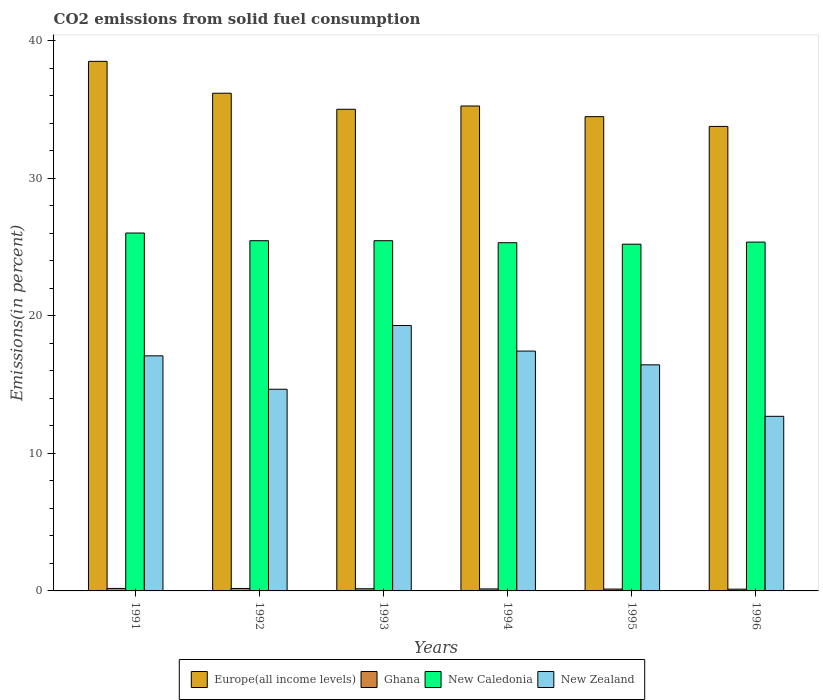How many groups of bars are there?
Offer a very short reply. 6. Are the number of bars on each tick of the X-axis equal?
Make the answer very short. Yes. In how many cases, is the number of bars for a given year not equal to the number of legend labels?
Ensure brevity in your answer.  0. What is the total CO2 emitted in Europe(all income levels) in 1994?
Provide a succinct answer. 35.26. Across all years, what is the maximum total CO2 emitted in Europe(all income levels)?
Your response must be concise. 38.51. Across all years, what is the minimum total CO2 emitted in New Zealand?
Ensure brevity in your answer.  12.7. In which year was the total CO2 emitted in Ghana maximum?
Ensure brevity in your answer.  1991. In which year was the total CO2 emitted in New Caledonia minimum?
Provide a succinct answer. 1995. What is the total total CO2 emitted in New Caledonia in the graph?
Your answer should be compact. 152.85. What is the difference between the total CO2 emitted in New Caledonia in 1993 and that in 1996?
Your answer should be very brief. 0.1. What is the difference between the total CO2 emitted in Europe(all income levels) in 1991 and the total CO2 emitted in New Caledonia in 1995?
Give a very brief answer. 13.29. What is the average total CO2 emitted in Europe(all income levels) per year?
Offer a very short reply. 35.54. In the year 1992, what is the difference between the total CO2 emitted in New Zealand and total CO2 emitted in Ghana?
Provide a short and direct response. 14.49. In how many years, is the total CO2 emitted in Ghana greater than 18 %?
Offer a very short reply. 0. What is the ratio of the total CO2 emitted in New Caledonia in 1992 to that in 1995?
Provide a short and direct response. 1.01. What is the difference between the highest and the second highest total CO2 emitted in New Caledonia?
Your answer should be very brief. 0.56. What is the difference between the highest and the lowest total CO2 emitted in Europe(all income levels)?
Your answer should be compact. 4.73. In how many years, is the total CO2 emitted in New Caledonia greater than the average total CO2 emitted in New Caledonia taken over all years?
Your answer should be very brief. 1. Is the sum of the total CO2 emitted in Ghana in 1994 and 1995 greater than the maximum total CO2 emitted in New Zealand across all years?
Provide a short and direct response. No. Is it the case that in every year, the sum of the total CO2 emitted in New Caledonia and total CO2 emitted in Ghana is greater than the sum of total CO2 emitted in New Zealand and total CO2 emitted in Europe(all income levels)?
Offer a very short reply. Yes. What does the 1st bar from the left in 1991 represents?
Provide a short and direct response. Europe(all income levels). What does the 1st bar from the right in 1995 represents?
Your answer should be compact. New Zealand. What is the difference between two consecutive major ticks on the Y-axis?
Your answer should be compact. 10. Are the values on the major ticks of Y-axis written in scientific E-notation?
Your answer should be very brief. No. Does the graph contain any zero values?
Ensure brevity in your answer.  No. What is the title of the graph?
Your response must be concise. CO2 emissions from solid fuel consumption. What is the label or title of the X-axis?
Offer a terse response. Years. What is the label or title of the Y-axis?
Ensure brevity in your answer.  Emissions(in percent). What is the Emissions(in percent) in Europe(all income levels) in 1991?
Your response must be concise. 38.51. What is the Emissions(in percent) in Ghana in 1991?
Provide a succinct answer. 0.18. What is the Emissions(in percent) in New Caledonia in 1991?
Your answer should be compact. 26.02. What is the Emissions(in percent) of New Zealand in 1991?
Offer a terse response. 17.09. What is the Emissions(in percent) in Europe(all income levels) in 1992?
Offer a terse response. 36.19. What is the Emissions(in percent) of Ghana in 1992?
Make the answer very short. 0.18. What is the Emissions(in percent) of New Caledonia in 1992?
Ensure brevity in your answer.  25.47. What is the Emissions(in percent) of New Zealand in 1992?
Provide a short and direct response. 14.67. What is the Emissions(in percent) in Europe(all income levels) in 1993?
Ensure brevity in your answer.  35.02. What is the Emissions(in percent) in Ghana in 1993?
Offer a terse response. 0.16. What is the Emissions(in percent) in New Caledonia in 1993?
Ensure brevity in your answer.  25.47. What is the Emissions(in percent) of New Zealand in 1993?
Ensure brevity in your answer.  19.3. What is the Emissions(in percent) in Europe(all income levels) in 1994?
Your answer should be very brief. 35.26. What is the Emissions(in percent) in Ghana in 1994?
Ensure brevity in your answer.  0.14. What is the Emissions(in percent) of New Caledonia in 1994?
Provide a succinct answer. 25.32. What is the Emissions(in percent) in New Zealand in 1994?
Keep it short and to the point. 17.44. What is the Emissions(in percent) of Europe(all income levels) in 1995?
Make the answer very short. 34.48. What is the Emissions(in percent) of Ghana in 1995?
Offer a terse response. 0.14. What is the Emissions(in percent) in New Caledonia in 1995?
Make the answer very short. 25.21. What is the Emissions(in percent) of New Zealand in 1995?
Offer a terse response. 16.44. What is the Emissions(in percent) of Europe(all income levels) in 1996?
Offer a very short reply. 33.78. What is the Emissions(in percent) in Ghana in 1996?
Keep it short and to the point. 0.13. What is the Emissions(in percent) in New Caledonia in 1996?
Your answer should be compact. 25.36. What is the Emissions(in percent) of New Zealand in 1996?
Keep it short and to the point. 12.7. Across all years, what is the maximum Emissions(in percent) in Europe(all income levels)?
Keep it short and to the point. 38.51. Across all years, what is the maximum Emissions(in percent) of Ghana?
Give a very brief answer. 0.18. Across all years, what is the maximum Emissions(in percent) of New Caledonia?
Offer a very short reply. 26.02. Across all years, what is the maximum Emissions(in percent) of New Zealand?
Provide a short and direct response. 19.3. Across all years, what is the minimum Emissions(in percent) in Europe(all income levels)?
Your response must be concise. 33.78. Across all years, what is the minimum Emissions(in percent) of Ghana?
Your answer should be compact. 0.13. Across all years, what is the minimum Emissions(in percent) of New Caledonia?
Provide a short and direct response. 25.21. Across all years, what is the minimum Emissions(in percent) of New Zealand?
Give a very brief answer. 12.7. What is the total Emissions(in percent) in Europe(all income levels) in the graph?
Ensure brevity in your answer.  213.24. What is the total Emissions(in percent) in Ghana in the graph?
Offer a very short reply. 0.92. What is the total Emissions(in percent) of New Caledonia in the graph?
Offer a terse response. 152.85. What is the total Emissions(in percent) in New Zealand in the graph?
Your response must be concise. 97.63. What is the difference between the Emissions(in percent) in Europe(all income levels) in 1991 and that in 1992?
Your response must be concise. 2.32. What is the difference between the Emissions(in percent) of Ghana in 1991 and that in 1992?
Your answer should be compact. 0. What is the difference between the Emissions(in percent) in New Caledonia in 1991 and that in 1992?
Make the answer very short. 0.56. What is the difference between the Emissions(in percent) in New Zealand in 1991 and that in 1992?
Your answer should be very brief. 2.43. What is the difference between the Emissions(in percent) in Europe(all income levels) in 1991 and that in 1993?
Make the answer very short. 3.48. What is the difference between the Emissions(in percent) in Ghana in 1991 and that in 1993?
Give a very brief answer. 0.02. What is the difference between the Emissions(in percent) of New Caledonia in 1991 and that in 1993?
Make the answer very short. 0.56. What is the difference between the Emissions(in percent) of New Zealand in 1991 and that in 1993?
Your answer should be very brief. -2.21. What is the difference between the Emissions(in percent) in Europe(all income levels) in 1991 and that in 1994?
Make the answer very short. 3.25. What is the difference between the Emissions(in percent) of Ghana in 1991 and that in 1994?
Offer a very short reply. 0.04. What is the difference between the Emissions(in percent) of New Caledonia in 1991 and that in 1994?
Provide a short and direct response. 0.71. What is the difference between the Emissions(in percent) of New Zealand in 1991 and that in 1994?
Provide a short and direct response. -0.35. What is the difference between the Emissions(in percent) of Europe(all income levels) in 1991 and that in 1995?
Ensure brevity in your answer.  4.02. What is the difference between the Emissions(in percent) of Ghana in 1991 and that in 1995?
Keep it short and to the point. 0.05. What is the difference between the Emissions(in percent) of New Caledonia in 1991 and that in 1995?
Provide a succinct answer. 0.81. What is the difference between the Emissions(in percent) of New Zealand in 1991 and that in 1995?
Make the answer very short. 0.65. What is the difference between the Emissions(in percent) of Europe(all income levels) in 1991 and that in 1996?
Provide a succinct answer. 4.73. What is the difference between the Emissions(in percent) in Ghana in 1991 and that in 1996?
Provide a succinct answer. 0.05. What is the difference between the Emissions(in percent) of New Caledonia in 1991 and that in 1996?
Ensure brevity in your answer.  0.66. What is the difference between the Emissions(in percent) of New Zealand in 1991 and that in 1996?
Ensure brevity in your answer.  4.4. What is the difference between the Emissions(in percent) in Europe(all income levels) in 1992 and that in 1993?
Your response must be concise. 1.17. What is the difference between the Emissions(in percent) in Ghana in 1992 and that in 1993?
Your answer should be very brief. 0.02. What is the difference between the Emissions(in percent) of New Caledonia in 1992 and that in 1993?
Give a very brief answer. 0. What is the difference between the Emissions(in percent) in New Zealand in 1992 and that in 1993?
Keep it short and to the point. -4.63. What is the difference between the Emissions(in percent) of Europe(all income levels) in 1992 and that in 1994?
Keep it short and to the point. 0.93. What is the difference between the Emissions(in percent) of Ghana in 1992 and that in 1994?
Keep it short and to the point. 0.03. What is the difference between the Emissions(in percent) of New Caledonia in 1992 and that in 1994?
Provide a short and direct response. 0.15. What is the difference between the Emissions(in percent) of New Zealand in 1992 and that in 1994?
Your answer should be very brief. -2.78. What is the difference between the Emissions(in percent) of Europe(all income levels) in 1992 and that in 1995?
Your response must be concise. 1.7. What is the difference between the Emissions(in percent) in Ghana in 1992 and that in 1995?
Your answer should be compact. 0.04. What is the difference between the Emissions(in percent) in New Caledonia in 1992 and that in 1995?
Offer a terse response. 0.25. What is the difference between the Emissions(in percent) in New Zealand in 1992 and that in 1995?
Provide a succinct answer. -1.77. What is the difference between the Emissions(in percent) in Europe(all income levels) in 1992 and that in 1996?
Your answer should be compact. 2.41. What is the difference between the Emissions(in percent) in Ghana in 1992 and that in 1996?
Keep it short and to the point. 0.05. What is the difference between the Emissions(in percent) in New Caledonia in 1992 and that in 1996?
Your response must be concise. 0.1. What is the difference between the Emissions(in percent) of New Zealand in 1992 and that in 1996?
Provide a short and direct response. 1.97. What is the difference between the Emissions(in percent) in Europe(all income levels) in 1993 and that in 1994?
Give a very brief answer. -0.24. What is the difference between the Emissions(in percent) of Ghana in 1993 and that in 1994?
Your answer should be compact. 0.01. What is the difference between the Emissions(in percent) of New Caledonia in 1993 and that in 1994?
Make the answer very short. 0.15. What is the difference between the Emissions(in percent) of New Zealand in 1993 and that in 1994?
Offer a very short reply. 1.86. What is the difference between the Emissions(in percent) in Europe(all income levels) in 1993 and that in 1995?
Offer a terse response. 0.54. What is the difference between the Emissions(in percent) in Ghana in 1993 and that in 1995?
Make the answer very short. 0.02. What is the difference between the Emissions(in percent) in New Caledonia in 1993 and that in 1995?
Provide a short and direct response. 0.25. What is the difference between the Emissions(in percent) of New Zealand in 1993 and that in 1995?
Ensure brevity in your answer.  2.86. What is the difference between the Emissions(in percent) in Europe(all income levels) in 1993 and that in 1996?
Your answer should be very brief. 1.25. What is the difference between the Emissions(in percent) in Ghana in 1993 and that in 1996?
Offer a terse response. 0.03. What is the difference between the Emissions(in percent) of New Caledonia in 1993 and that in 1996?
Keep it short and to the point. 0.1. What is the difference between the Emissions(in percent) in New Zealand in 1993 and that in 1996?
Keep it short and to the point. 6.6. What is the difference between the Emissions(in percent) of Europe(all income levels) in 1994 and that in 1995?
Make the answer very short. 0.78. What is the difference between the Emissions(in percent) of Ghana in 1994 and that in 1995?
Offer a terse response. 0.01. What is the difference between the Emissions(in percent) in New Caledonia in 1994 and that in 1995?
Make the answer very short. 0.11. What is the difference between the Emissions(in percent) in Europe(all income levels) in 1994 and that in 1996?
Offer a terse response. 1.49. What is the difference between the Emissions(in percent) of Ghana in 1994 and that in 1996?
Your answer should be very brief. 0.02. What is the difference between the Emissions(in percent) in New Caledonia in 1994 and that in 1996?
Provide a short and direct response. -0.04. What is the difference between the Emissions(in percent) in New Zealand in 1994 and that in 1996?
Keep it short and to the point. 4.74. What is the difference between the Emissions(in percent) in Europe(all income levels) in 1995 and that in 1996?
Offer a terse response. 0.71. What is the difference between the Emissions(in percent) in Ghana in 1995 and that in 1996?
Offer a very short reply. 0.01. What is the difference between the Emissions(in percent) in New Caledonia in 1995 and that in 1996?
Your answer should be compact. -0.15. What is the difference between the Emissions(in percent) in New Zealand in 1995 and that in 1996?
Your response must be concise. 3.74. What is the difference between the Emissions(in percent) of Europe(all income levels) in 1991 and the Emissions(in percent) of Ghana in 1992?
Offer a terse response. 38.33. What is the difference between the Emissions(in percent) in Europe(all income levels) in 1991 and the Emissions(in percent) in New Caledonia in 1992?
Your answer should be compact. 13.04. What is the difference between the Emissions(in percent) in Europe(all income levels) in 1991 and the Emissions(in percent) in New Zealand in 1992?
Your answer should be compact. 23.84. What is the difference between the Emissions(in percent) in Ghana in 1991 and the Emissions(in percent) in New Caledonia in 1992?
Make the answer very short. -25.28. What is the difference between the Emissions(in percent) of Ghana in 1991 and the Emissions(in percent) of New Zealand in 1992?
Make the answer very short. -14.48. What is the difference between the Emissions(in percent) in New Caledonia in 1991 and the Emissions(in percent) in New Zealand in 1992?
Keep it short and to the point. 11.36. What is the difference between the Emissions(in percent) of Europe(all income levels) in 1991 and the Emissions(in percent) of Ghana in 1993?
Ensure brevity in your answer.  38.35. What is the difference between the Emissions(in percent) of Europe(all income levels) in 1991 and the Emissions(in percent) of New Caledonia in 1993?
Your answer should be very brief. 13.04. What is the difference between the Emissions(in percent) in Europe(all income levels) in 1991 and the Emissions(in percent) in New Zealand in 1993?
Ensure brevity in your answer.  19.21. What is the difference between the Emissions(in percent) of Ghana in 1991 and the Emissions(in percent) of New Caledonia in 1993?
Make the answer very short. -25.28. What is the difference between the Emissions(in percent) of Ghana in 1991 and the Emissions(in percent) of New Zealand in 1993?
Provide a succinct answer. -19.12. What is the difference between the Emissions(in percent) in New Caledonia in 1991 and the Emissions(in percent) in New Zealand in 1993?
Offer a terse response. 6.73. What is the difference between the Emissions(in percent) in Europe(all income levels) in 1991 and the Emissions(in percent) in Ghana in 1994?
Provide a short and direct response. 38.36. What is the difference between the Emissions(in percent) in Europe(all income levels) in 1991 and the Emissions(in percent) in New Caledonia in 1994?
Offer a very short reply. 13.19. What is the difference between the Emissions(in percent) in Europe(all income levels) in 1991 and the Emissions(in percent) in New Zealand in 1994?
Make the answer very short. 21.07. What is the difference between the Emissions(in percent) in Ghana in 1991 and the Emissions(in percent) in New Caledonia in 1994?
Make the answer very short. -25.14. What is the difference between the Emissions(in percent) in Ghana in 1991 and the Emissions(in percent) in New Zealand in 1994?
Make the answer very short. -17.26. What is the difference between the Emissions(in percent) in New Caledonia in 1991 and the Emissions(in percent) in New Zealand in 1994?
Your answer should be compact. 8.58. What is the difference between the Emissions(in percent) in Europe(all income levels) in 1991 and the Emissions(in percent) in Ghana in 1995?
Your response must be concise. 38.37. What is the difference between the Emissions(in percent) of Europe(all income levels) in 1991 and the Emissions(in percent) of New Caledonia in 1995?
Your answer should be compact. 13.29. What is the difference between the Emissions(in percent) in Europe(all income levels) in 1991 and the Emissions(in percent) in New Zealand in 1995?
Your response must be concise. 22.07. What is the difference between the Emissions(in percent) of Ghana in 1991 and the Emissions(in percent) of New Caledonia in 1995?
Provide a short and direct response. -25.03. What is the difference between the Emissions(in percent) in Ghana in 1991 and the Emissions(in percent) in New Zealand in 1995?
Provide a short and direct response. -16.26. What is the difference between the Emissions(in percent) of New Caledonia in 1991 and the Emissions(in percent) of New Zealand in 1995?
Ensure brevity in your answer.  9.59. What is the difference between the Emissions(in percent) in Europe(all income levels) in 1991 and the Emissions(in percent) in Ghana in 1996?
Your answer should be very brief. 38.38. What is the difference between the Emissions(in percent) in Europe(all income levels) in 1991 and the Emissions(in percent) in New Caledonia in 1996?
Offer a terse response. 13.14. What is the difference between the Emissions(in percent) of Europe(all income levels) in 1991 and the Emissions(in percent) of New Zealand in 1996?
Provide a short and direct response. 25.81. What is the difference between the Emissions(in percent) in Ghana in 1991 and the Emissions(in percent) in New Caledonia in 1996?
Keep it short and to the point. -25.18. What is the difference between the Emissions(in percent) in Ghana in 1991 and the Emissions(in percent) in New Zealand in 1996?
Make the answer very short. -12.51. What is the difference between the Emissions(in percent) in New Caledonia in 1991 and the Emissions(in percent) in New Zealand in 1996?
Your response must be concise. 13.33. What is the difference between the Emissions(in percent) in Europe(all income levels) in 1992 and the Emissions(in percent) in Ghana in 1993?
Your answer should be compact. 36.03. What is the difference between the Emissions(in percent) in Europe(all income levels) in 1992 and the Emissions(in percent) in New Caledonia in 1993?
Your answer should be very brief. 10.72. What is the difference between the Emissions(in percent) in Europe(all income levels) in 1992 and the Emissions(in percent) in New Zealand in 1993?
Ensure brevity in your answer.  16.89. What is the difference between the Emissions(in percent) of Ghana in 1992 and the Emissions(in percent) of New Caledonia in 1993?
Provide a succinct answer. -25.29. What is the difference between the Emissions(in percent) of Ghana in 1992 and the Emissions(in percent) of New Zealand in 1993?
Offer a very short reply. -19.12. What is the difference between the Emissions(in percent) of New Caledonia in 1992 and the Emissions(in percent) of New Zealand in 1993?
Make the answer very short. 6.17. What is the difference between the Emissions(in percent) of Europe(all income levels) in 1992 and the Emissions(in percent) of Ghana in 1994?
Offer a terse response. 36.04. What is the difference between the Emissions(in percent) of Europe(all income levels) in 1992 and the Emissions(in percent) of New Caledonia in 1994?
Give a very brief answer. 10.87. What is the difference between the Emissions(in percent) in Europe(all income levels) in 1992 and the Emissions(in percent) in New Zealand in 1994?
Provide a short and direct response. 18.75. What is the difference between the Emissions(in percent) of Ghana in 1992 and the Emissions(in percent) of New Caledonia in 1994?
Offer a very short reply. -25.14. What is the difference between the Emissions(in percent) in Ghana in 1992 and the Emissions(in percent) in New Zealand in 1994?
Offer a terse response. -17.26. What is the difference between the Emissions(in percent) in New Caledonia in 1992 and the Emissions(in percent) in New Zealand in 1994?
Give a very brief answer. 8.03. What is the difference between the Emissions(in percent) of Europe(all income levels) in 1992 and the Emissions(in percent) of Ghana in 1995?
Your answer should be very brief. 36.05. What is the difference between the Emissions(in percent) of Europe(all income levels) in 1992 and the Emissions(in percent) of New Caledonia in 1995?
Your answer should be compact. 10.98. What is the difference between the Emissions(in percent) in Europe(all income levels) in 1992 and the Emissions(in percent) in New Zealand in 1995?
Provide a succinct answer. 19.75. What is the difference between the Emissions(in percent) in Ghana in 1992 and the Emissions(in percent) in New Caledonia in 1995?
Offer a terse response. -25.03. What is the difference between the Emissions(in percent) of Ghana in 1992 and the Emissions(in percent) of New Zealand in 1995?
Your response must be concise. -16.26. What is the difference between the Emissions(in percent) of New Caledonia in 1992 and the Emissions(in percent) of New Zealand in 1995?
Offer a very short reply. 9.03. What is the difference between the Emissions(in percent) of Europe(all income levels) in 1992 and the Emissions(in percent) of Ghana in 1996?
Provide a succinct answer. 36.06. What is the difference between the Emissions(in percent) of Europe(all income levels) in 1992 and the Emissions(in percent) of New Caledonia in 1996?
Provide a succinct answer. 10.83. What is the difference between the Emissions(in percent) in Europe(all income levels) in 1992 and the Emissions(in percent) in New Zealand in 1996?
Provide a short and direct response. 23.49. What is the difference between the Emissions(in percent) in Ghana in 1992 and the Emissions(in percent) in New Caledonia in 1996?
Provide a short and direct response. -25.18. What is the difference between the Emissions(in percent) of Ghana in 1992 and the Emissions(in percent) of New Zealand in 1996?
Your answer should be compact. -12.52. What is the difference between the Emissions(in percent) of New Caledonia in 1992 and the Emissions(in percent) of New Zealand in 1996?
Make the answer very short. 12.77. What is the difference between the Emissions(in percent) in Europe(all income levels) in 1993 and the Emissions(in percent) in Ghana in 1994?
Offer a terse response. 34.88. What is the difference between the Emissions(in percent) of Europe(all income levels) in 1993 and the Emissions(in percent) of New Caledonia in 1994?
Provide a short and direct response. 9.7. What is the difference between the Emissions(in percent) in Europe(all income levels) in 1993 and the Emissions(in percent) in New Zealand in 1994?
Offer a terse response. 17.58. What is the difference between the Emissions(in percent) of Ghana in 1993 and the Emissions(in percent) of New Caledonia in 1994?
Your answer should be very brief. -25.16. What is the difference between the Emissions(in percent) in Ghana in 1993 and the Emissions(in percent) in New Zealand in 1994?
Give a very brief answer. -17.28. What is the difference between the Emissions(in percent) of New Caledonia in 1993 and the Emissions(in percent) of New Zealand in 1994?
Ensure brevity in your answer.  8.03. What is the difference between the Emissions(in percent) in Europe(all income levels) in 1993 and the Emissions(in percent) in Ghana in 1995?
Your answer should be very brief. 34.89. What is the difference between the Emissions(in percent) in Europe(all income levels) in 1993 and the Emissions(in percent) in New Caledonia in 1995?
Give a very brief answer. 9.81. What is the difference between the Emissions(in percent) of Europe(all income levels) in 1993 and the Emissions(in percent) of New Zealand in 1995?
Your answer should be compact. 18.58. What is the difference between the Emissions(in percent) in Ghana in 1993 and the Emissions(in percent) in New Caledonia in 1995?
Your response must be concise. -25.05. What is the difference between the Emissions(in percent) in Ghana in 1993 and the Emissions(in percent) in New Zealand in 1995?
Your answer should be compact. -16.28. What is the difference between the Emissions(in percent) in New Caledonia in 1993 and the Emissions(in percent) in New Zealand in 1995?
Give a very brief answer. 9.03. What is the difference between the Emissions(in percent) in Europe(all income levels) in 1993 and the Emissions(in percent) in Ghana in 1996?
Your response must be concise. 34.89. What is the difference between the Emissions(in percent) of Europe(all income levels) in 1993 and the Emissions(in percent) of New Caledonia in 1996?
Your answer should be compact. 9.66. What is the difference between the Emissions(in percent) of Europe(all income levels) in 1993 and the Emissions(in percent) of New Zealand in 1996?
Keep it short and to the point. 22.33. What is the difference between the Emissions(in percent) of Ghana in 1993 and the Emissions(in percent) of New Caledonia in 1996?
Ensure brevity in your answer.  -25.21. What is the difference between the Emissions(in percent) in Ghana in 1993 and the Emissions(in percent) in New Zealand in 1996?
Offer a very short reply. -12.54. What is the difference between the Emissions(in percent) of New Caledonia in 1993 and the Emissions(in percent) of New Zealand in 1996?
Ensure brevity in your answer.  12.77. What is the difference between the Emissions(in percent) in Europe(all income levels) in 1994 and the Emissions(in percent) in Ghana in 1995?
Provide a short and direct response. 35.13. What is the difference between the Emissions(in percent) in Europe(all income levels) in 1994 and the Emissions(in percent) in New Caledonia in 1995?
Offer a terse response. 10.05. What is the difference between the Emissions(in percent) of Europe(all income levels) in 1994 and the Emissions(in percent) of New Zealand in 1995?
Provide a succinct answer. 18.82. What is the difference between the Emissions(in percent) in Ghana in 1994 and the Emissions(in percent) in New Caledonia in 1995?
Give a very brief answer. -25.07. What is the difference between the Emissions(in percent) in Ghana in 1994 and the Emissions(in percent) in New Zealand in 1995?
Provide a succinct answer. -16.29. What is the difference between the Emissions(in percent) in New Caledonia in 1994 and the Emissions(in percent) in New Zealand in 1995?
Offer a terse response. 8.88. What is the difference between the Emissions(in percent) in Europe(all income levels) in 1994 and the Emissions(in percent) in Ghana in 1996?
Keep it short and to the point. 35.13. What is the difference between the Emissions(in percent) of Europe(all income levels) in 1994 and the Emissions(in percent) of New Caledonia in 1996?
Offer a very short reply. 9.9. What is the difference between the Emissions(in percent) in Europe(all income levels) in 1994 and the Emissions(in percent) in New Zealand in 1996?
Provide a short and direct response. 22.57. What is the difference between the Emissions(in percent) of Ghana in 1994 and the Emissions(in percent) of New Caledonia in 1996?
Make the answer very short. -25.22. What is the difference between the Emissions(in percent) in Ghana in 1994 and the Emissions(in percent) in New Zealand in 1996?
Your answer should be very brief. -12.55. What is the difference between the Emissions(in percent) of New Caledonia in 1994 and the Emissions(in percent) of New Zealand in 1996?
Your answer should be compact. 12.62. What is the difference between the Emissions(in percent) of Europe(all income levels) in 1995 and the Emissions(in percent) of Ghana in 1996?
Offer a terse response. 34.36. What is the difference between the Emissions(in percent) in Europe(all income levels) in 1995 and the Emissions(in percent) in New Caledonia in 1996?
Offer a very short reply. 9.12. What is the difference between the Emissions(in percent) of Europe(all income levels) in 1995 and the Emissions(in percent) of New Zealand in 1996?
Provide a short and direct response. 21.79. What is the difference between the Emissions(in percent) of Ghana in 1995 and the Emissions(in percent) of New Caledonia in 1996?
Make the answer very short. -25.23. What is the difference between the Emissions(in percent) of Ghana in 1995 and the Emissions(in percent) of New Zealand in 1996?
Make the answer very short. -12.56. What is the difference between the Emissions(in percent) in New Caledonia in 1995 and the Emissions(in percent) in New Zealand in 1996?
Your answer should be very brief. 12.52. What is the average Emissions(in percent) in Europe(all income levels) per year?
Your response must be concise. 35.54. What is the average Emissions(in percent) of Ghana per year?
Your answer should be very brief. 0.15. What is the average Emissions(in percent) of New Caledonia per year?
Provide a short and direct response. 25.48. What is the average Emissions(in percent) in New Zealand per year?
Provide a succinct answer. 16.27. In the year 1991, what is the difference between the Emissions(in percent) in Europe(all income levels) and Emissions(in percent) in Ghana?
Your answer should be very brief. 38.33. In the year 1991, what is the difference between the Emissions(in percent) of Europe(all income levels) and Emissions(in percent) of New Caledonia?
Your answer should be very brief. 12.48. In the year 1991, what is the difference between the Emissions(in percent) in Europe(all income levels) and Emissions(in percent) in New Zealand?
Your answer should be compact. 21.41. In the year 1991, what is the difference between the Emissions(in percent) in Ghana and Emissions(in percent) in New Caledonia?
Give a very brief answer. -25.84. In the year 1991, what is the difference between the Emissions(in percent) of Ghana and Emissions(in percent) of New Zealand?
Offer a very short reply. -16.91. In the year 1991, what is the difference between the Emissions(in percent) in New Caledonia and Emissions(in percent) in New Zealand?
Offer a terse response. 8.93. In the year 1992, what is the difference between the Emissions(in percent) of Europe(all income levels) and Emissions(in percent) of Ghana?
Your answer should be compact. 36.01. In the year 1992, what is the difference between the Emissions(in percent) of Europe(all income levels) and Emissions(in percent) of New Caledonia?
Make the answer very short. 10.72. In the year 1992, what is the difference between the Emissions(in percent) in Europe(all income levels) and Emissions(in percent) in New Zealand?
Your answer should be compact. 21.52. In the year 1992, what is the difference between the Emissions(in percent) in Ghana and Emissions(in percent) in New Caledonia?
Your answer should be compact. -25.29. In the year 1992, what is the difference between the Emissions(in percent) of Ghana and Emissions(in percent) of New Zealand?
Ensure brevity in your answer.  -14.49. In the year 1992, what is the difference between the Emissions(in percent) in New Caledonia and Emissions(in percent) in New Zealand?
Make the answer very short. 10.8. In the year 1993, what is the difference between the Emissions(in percent) of Europe(all income levels) and Emissions(in percent) of Ghana?
Make the answer very short. 34.86. In the year 1993, what is the difference between the Emissions(in percent) in Europe(all income levels) and Emissions(in percent) in New Caledonia?
Your response must be concise. 9.56. In the year 1993, what is the difference between the Emissions(in percent) in Europe(all income levels) and Emissions(in percent) in New Zealand?
Keep it short and to the point. 15.72. In the year 1993, what is the difference between the Emissions(in percent) in Ghana and Emissions(in percent) in New Caledonia?
Your answer should be compact. -25.31. In the year 1993, what is the difference between the Emissions(in percent) of Ghana and Emissions(in percent) of New Zealand?
Your answer should be very brief. -19.14. In the year 1993, what is the difference between the Emissions(in percent) in New Caledonia and Emissions(in percent) in New Zealand?
Give a very brief answer. 6.17. In the year 1994, what is the difference between the Emissions(in percent) in Europe(all income levels) and Emissions(in percent) in Ghana?
Ensure brevity in your answer.  35.12. In the year 1994, what is the difference between the Emissions(in percent) of Europe(all income levels) and Emissions(in percent) of New Caledonia?
Keep it short and to the point. 9.94. In the year 1994, what is the difference between the Emissions(in percent) of Europe(all income levels) and Emissions(in percent) of New Zealand?
Provide a short and direct response. 17.82. In the year 1994, what is the difference between the Emissions(in percent) in Ghana and Emissions(in percent) in New Caledonia?
Keep it short and to the point. -25.17. In the year 1994, what is the difference between the Emissions(in percent) of Ghana and Emissions(in percent) of New Zealand?
Keep it short and to the point. -17.3. In the year 1994, what is the difference between the Emissions(in percent) of New Caledonia and Emissions(in percent) of New Zealand?
Make the answer very short. 7.88. In the year 1995, what is the difference between the Emissions(in percent) of Europe(all income levels) and Emissions(in percent) of Ghana?
Give a very brief answer. 34.35. In the year 1995, what is the difference between the Emissions(in percent) of Europe(all income levels) and Emissions(in percent) of New Caledonia?
Offer a very short reply. 9.27. In the year 1995, what is the difference between the Emissions(in percent) of Europe(all income levels) and Emissions(in percent) of New Zealand?
Your answer should be compact. 18.05. In the year 1995, what is the difference between the Emissions(in percent) of Ghana and Emissions(in percent) of New Caledonia?
Provide a short and direct response. -25.08. In the year 1995, what is the difference between the Emissions(in percent) of Ghana and Emissions(in percent) of New Zealand?
Your response must be concise. -16.3. In the year 1995, what is the difference between the Emissions(in percent) of New Caledonia and Emissions(in percent) of New Zealand?
Ensure brevity in your answer.  8.77. In the year 1996, what is the difference between the Emissions(in percent) of Europe(all income levels) and Emissions(in percent) of Ghana?
Your answer should be compact. 33.65. In the year 1996, what is the difference between the Emissions(in percent) in Europe(all income levels) and Emissions(in percent) in New Caledonia?
Your answer should be compact. 8.41. In the year 1996, what is the difference between the Emissions(in percent) in Europe(all income levels) and Emissions(in percent) in New Zealand?
Give a very brief answer. 21.08. In the year 1996, what is the difference between the Emissions(in percent) in Ghana and Emissions(in percent) in New Caledonia?
Provide a short and direct response. -25.24. In the year 1996, what is the difference between the Emissions(in percent) of Ghana and Emissions(in percent) of New Zealand?
Give a very brief answer. -12.57. In the year 1996, what is the difference between the Emissions(in percent) of New Caledonia and Emissions(in percent) of New Zealand?
Provide a short and direct response. 12.67. What is the ratio of the Emissions(in percent) of Europe(all income levels) in 1991 to that in 1992?
Keep it short and to the point. 1.06. What is the ratio of the Emissions(in percent) in Ghana in 1991 to that in 1992?
Your response must be concise. 1.01. What is the ratio of the Emissions(in percent) in New Caledonia in 1991 to that in 1992?
Your answer should be very brief. 1.02. What is the ratio of the Emissions(in percent) in New Zealand in 1991 to that in 1992?
Your response must be concise. 1.17. What is the ratio of the Emissions(in percent) of Europe(all income levels) in 1991 to that in 1993?
Give a very brief answer. 1.1. What is the ratio of the Emissions(in percent) of Ghana in 1991 to that in 1993?
Your answer should be very brief. 1.15. What is the ratio of the Emissions(in percent) in New Caledonia in 1991 to that in 1993?
Give a very brief answer. 1.02. What is the ratio of the Emissions(in percent) in New Zealand in 1991 to that in 1993?
Give a very brief answer. 0.89. What is the ratio of the Emissions(in percent) of Europe(all income levels) in 1991 to that in 1994?
Keep it short and to the point. 1.09. What is the ratio of the Emissions(in percent) in Ghana in 1991 to that in 1994?
Provide a succinct answer. 1.25. What is the ratio of the Emissions(in percent) in New Caledonia in 1991 to that in 1994?
Offer a terse response. 1.03. What is the ratio of the Emissions(in percent) of New Zealand in 1991 to that in 1994?
Keep it short and to the point. 0.98. What is the ratio of the Emissions(in percent) in Europe(all income levels) in 1991 to that in 1995?
Offer a very short reply. 1.12. What is the ratio of the Emissions(in percent) of Ghana in 1991 to that in 1995?
Offer a very short reply. 1.34. What is the ratio of the Emissions(in percent) in New Caledonia in 1991 to that in 1995?
Keep it short and to the point. 1.03. What is the ratio of the Emissions(in percent) of New Zealand in 1991 to that in 1995?
Provide a succinct answer. 1.04. What is the ratio of the Emissions(in percent) in Europe(all income levels) in 1991 to that in 1996?
Keep it short and to the point. 1.14. What is the ratio of the Emissions(in percent) of Ghana in 1991 to that in 1996?
Keep it short and to the point. 1.42. What is the ratio of the Emissions(in percent) of New Caledonia in 1991 to that in 1996?
Provide a succinct answer. 1.03. What is the ratio of the Emissions(in percent) of New Zealand in 1991 to that in 1996?
Offer a terse response. 1.35. What is the ratio of the Emissions(in percent) of Europe(all income levels) in 1992 to that in 1993?
Your answer should be compact. 1.03. What is the ratio of the Emissions(in percent) in Ghana in 1992 to that in 1993?
Provide a short and direct response. 1.14. What is the ratio of the Emissions(in percent) of New Zealand in 1992 to that in 1993?
Offer a very short reply. 0.76. What is the ratio of the Emissions(in percent) of Europe(all income levels) in 1992 to that in 1994?
Keep it short and to the point. 1.03. What is the ratio of the Emissions(in percent) of Ghana in 1992 to that in 1994?
Provide a short and direct response. 1.24. What is the ratio of the Emissions(in percent) in New Zealand in 1992 to that in 1994?
Offer a terse response. 0.84. What is the ratio of the Emissions(in percent) of Europe(all income levels) in 1992 to that in 1995?
Ensure brevity in your answer.  1.05. What is the ratio of the Emissions(in percent) of Ghana in 1992 to that in 1995?
Your response must be concise. 1.32. What is the ratio of the Emissions(in percent) of New Caledonia in 1992 to that in 1995?
Your answer should be compact. 1.01. What is the ratio of the Emissions(in percent) in New Zealand in 1992 to that in 1995?
Ensure brevity in your answer.  0.89. What is the ratio of the Emissions(in percent) of Europe(all income levels) in 1992 to that in 1996?
Ensure brevity in your answer.  1.07. What is the ratio of the Emissions(in percent) of Ghana in 1992 to that in 1996?
Provide a succinct answer. 1.41. What is the ratio of the Emissions(in percent) in New Caledonia in 1992 to that in 1996?
Make the answer very short. 1. What is the ratio of the Emissions(in percent) of New Zealand in 1992 to that in 1996?
Give a very brief answer. 1.16. What is the ratio of the Emissions(in percent) of Ghana in 1993 to that in 1994?
Offer a terse response. 1.09. What is the ratio of the Emissions(in percent) in New Zealand in 1993 to that in 1994?
Offer a terse response. 1.11. What is the ratio of the Emissions(in percent) of Europe(all income levels) in 1993 to that in 1995?
Ensure brevity in your answer.  1.02. What is the ratio of the Emissions(in percent) in Ghana in 1993 to that in 1995?
Offer a very short reply. 1.16. What is the ratio of the Emissions(in percent) in New Zealand in 1993 to that in 1995?
Offer a terse response. 1.17. What is the ratio of the Emissions(in percent) of Europe(all income levels) in 1993 to that in 1996?
Provide a succinct answer. 1.04. What is the ratio of the Emissions(in percent) of Ghana in 1993 to that in 1996?
Your answer should be compact. 1.23. What is the ratio of the Emissions(in percent) in New Zealand in 1993 to that in 1996?
Offer a terse response. 1.52. What is the ratio of the Emissions(in percent) in Europe(all income levels) in 1994 to that in 1995?
Ensure brevity in your answer.  1.02. What is the ratio of the Emissions(in percent) of Ghana in 1994 to that in 1995?
Offer a very short reply. 1.07. What is the ratio of the Emissions(in percent) in New Caledonia in 1994 to that in 1995?
Provide a succinct answer. 1. What is the ratio of the Emissions(in percent) of New Zealand in 1994 to that in 1995?
Give a very brief answer. 1.06. What is the ratio of the Emissions(in percent) of Europe(all income levels) in 1994 to that in 1996?
Give a very brief answer. 1.04. What is the ratio of the Emissions(in percent) of Ghana in 1994 to that in 1996?
Keep it short and to the point. 1.14. What is the ratio of the Emissions(in percent) of New Zealand in 1994 to that in 1996?
Your response must be concise. 1.37. What is the ratio of the Emissions(in percent) of Ghana in 1995 to that in 1996?
Give a very brief answer. 1.06. What is the ratio of the Emissions(in percent) of New Caledonia in 1995 to that in 1996?
Provide a short and direct response. 0.99. What is the ratio of the Emissions(in percent) in New Zealand in 1995 to that in 1996?
Give a very brief answer. 1.29. What is the difference between the highest and the second highest Emissions(in percent) in Europe(all income levels)?
Make the answer very short. 2.32. What is the difference between the highest and the second highest Emissions(in percent) of Ghana?
Offer a terse response. 0. What is the difference between the highest and the second highest Emissions(in percent) in New Caledonia?
Your answer should be compact. 0.56. What is the difference between the highest and the second highest Emissions(in percent) in New Zealand?
Offer a terse response. 1.86. What is the difference between the highest and the lowest Emissions(in percent) of Europe(all income levels)?
Ensure brevity in your answer.  4.73. What is the difference between the highest and the lowest Emissions(in percent) of Ghana?
Keep it short and to the point. 0.05. What is the difference between the highest and the lowest Emissions(in percent) in New Caledonia?
Provide a short and direct response. 0.81. What is the difference between the highest and the lowest Emissions(in percent) of New Zealand?
Provide a short and direct response. 6.6. 